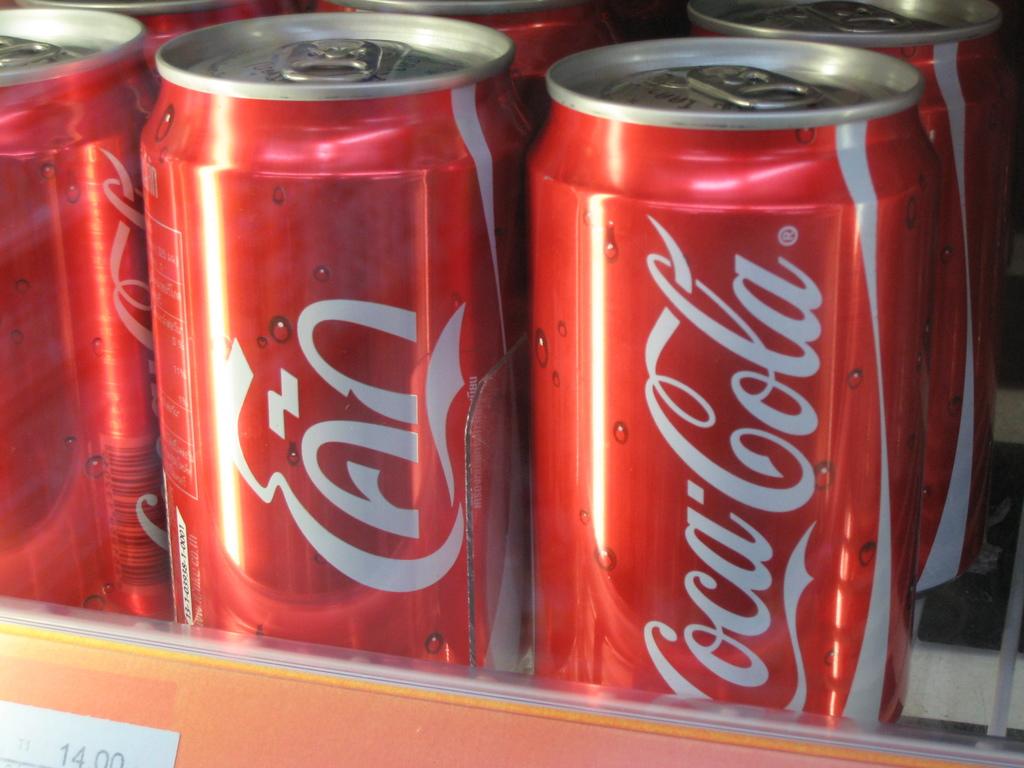What is the name of this soda?
Give a very brief answer. Coca cola. 